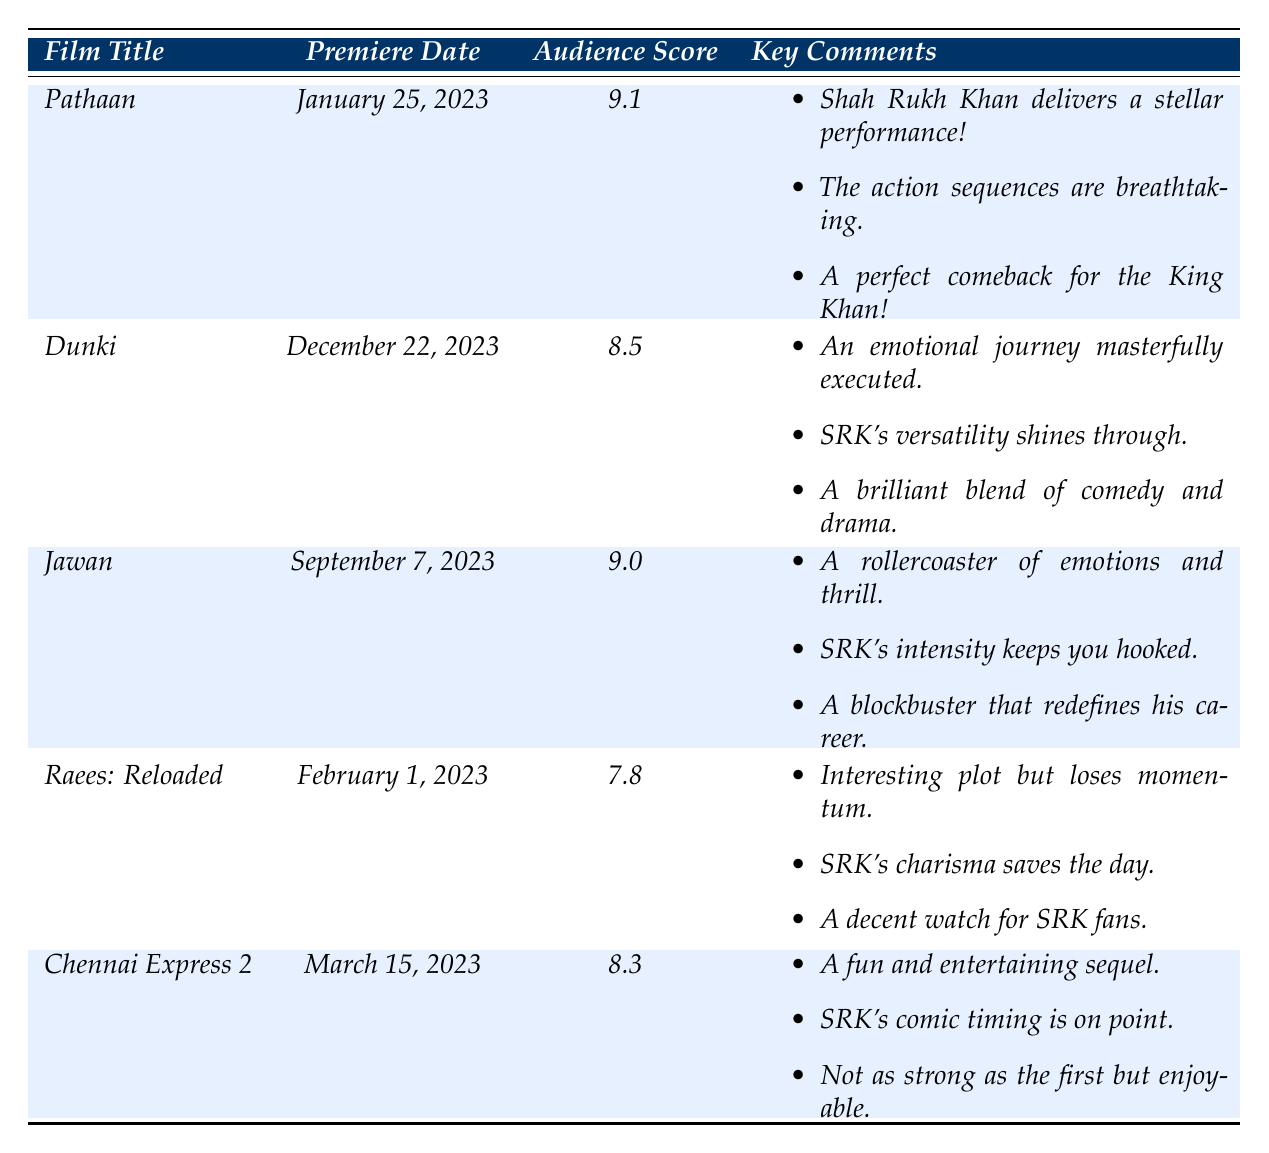What is the audience reaction score for "Pathaan"? The table lists "Pathaan" with an audience reaction score of 9.1.
Answer: 9.1 Which film had the highest audience reaction score? Comparing all the audience scores in the table, "Pathaan" has the highest score of 9.1.
Answer: Pathaan What are the key comments for "Jawan"? The key comments for "Jawan" are listed as: "A rollercoaster of emotions and thrill," "SRK's intensity keeps you hooked," and "A blockbuster that redefines his career."
Answer: A rollercoaster of emotions and thrill; SRK's intensity keeps you hooked; A blockbuster that redefines his career What is the score difference between "Dunki" and "Raees: Reloaded"? The score for "Dunki" is 8.5 and the score for "Raees: Reloaded" is 7.8. The difference is 8.5 - 7.8 = 0.7.
Answer: 0.7 What is the average audience reaction score of all films in the table? The scores are 9.1, 8.5, 9.0, 7.8, and 8.3. Adding these gives 9.1 + 8.5 + 9.0 + 7.8 + 8.3 = 42.7. There are 5 films, so the average is 42.7 / 5 = 8.54.
Answer: 8.54 Was "Chennai Express 2" better received than "Raees: Reloaded"? "Chennai Express 2" has an audience score of 8.3, while "Raees: Reloaded" has a score of 7.8. Since 8.3 is greater than 7.8, "Chennai Express 2" was better received.
Answer: Yes Which film had key comments emphasizing Shah Rukh Khan's versatility? The key comments for "Dunki" specifically mention SRK's versatility, indicating this film highlighted his varied acting skills.
Answer: Dunki How many films received an audience score of 9.0 or higher? The films with scores of 9.0 or higher are "Pathaan" (9.1) and "Jawan" (9.0). This totals to 2 films.
Answer: 2 Did any film premiere in February? The table shows that "Raees: Reloaded" premiered on February 1, 2023, confirming that there was a film premiere in that month.
Answer: Yes What is the relationship between Shah Rukh Khan's performance and audience scores in these premieres? Generally, higher audience scores, such as for "Pathaan" and "Jawan," correlate with positive comments about Shah Rukh Khan's performances, indicating that audience reactions are often influenced by his acting quality.
Answer: Positive correlation 